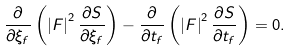<formula> <loc_0><loc_0><loc_500><loc_500>\frac { \partial } { \partial { \xi _ { f } } } \left ( \left | F \right | ^ { 2 } \frac { \partial { S } } { \partial { \xi _ { f } } } \right ) - \frac { \partial } { \partial { t _ { f } } } \left ( \left | F \right | ^ { 2 } \frac { \partial { S } } { \partial { t _ { f } } } \right ) = 0 .</formula> 